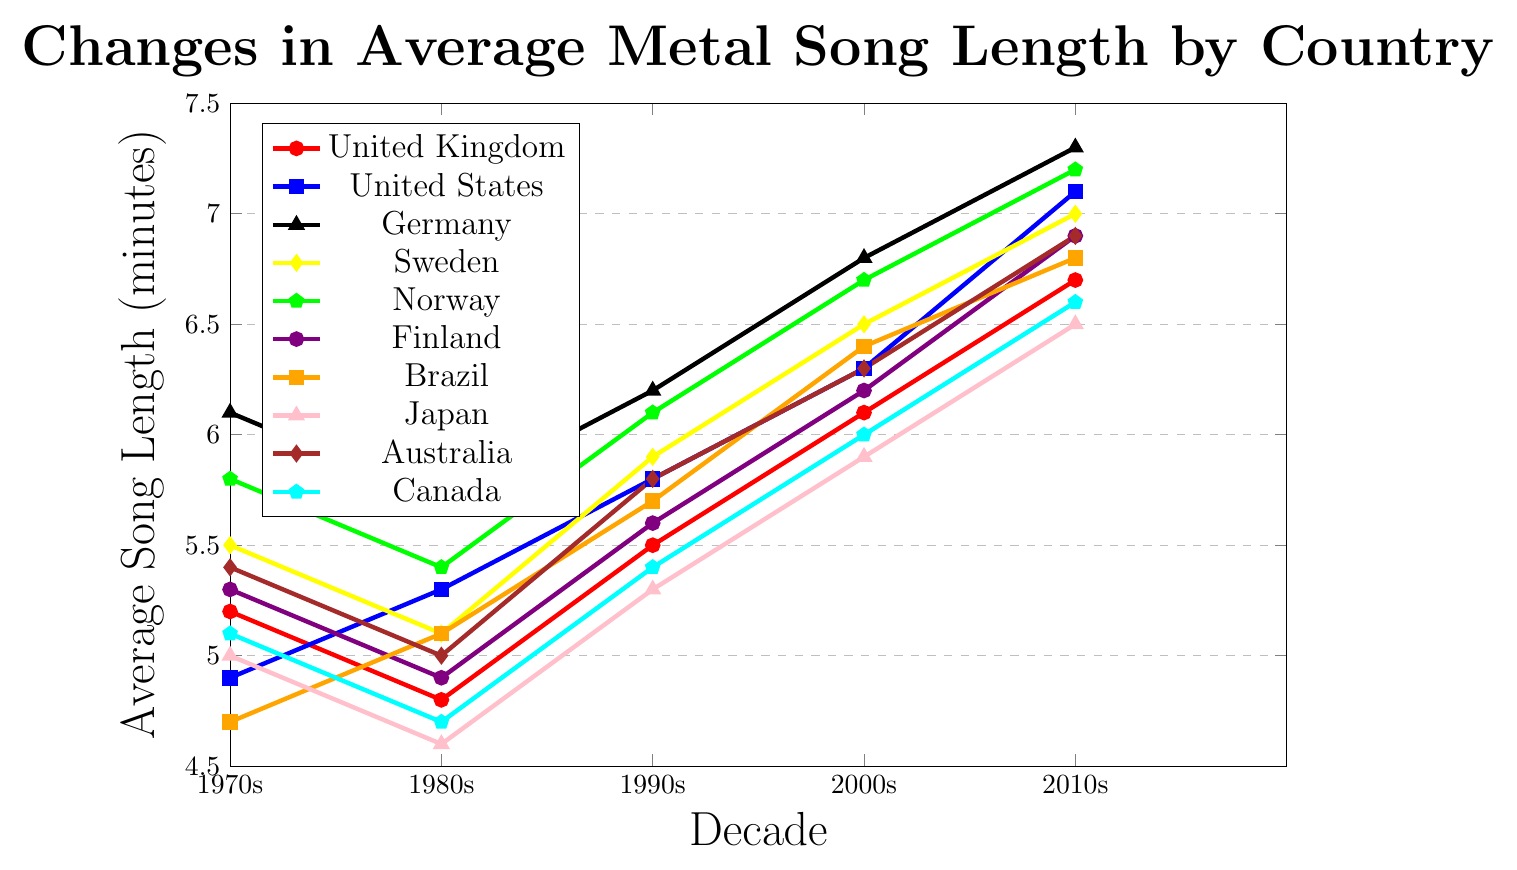Which country had the longest average song length in the 1970s? Look at the values for average song length in the 1970s for each country and find the highest value. Germany had an average song length of 6.1 minutes in the 1970s, which is the longest among all the countries.
Answer: Germany How did the average song length change for the United Kingdom from the 1980s to the 2010s? Refer to the average song lengths for the United Kingdom in the 1980s and the 2010s: 4.8 minutes and 6.7 minutes respectively. Subtract the value for the 1980s from the value for the 2010s: 6.7 - 4.8 = 1.9 minutes.
Answer: Increased by 1.9 minutes Which two countries had the closest average song lengths in the 2000s? Compare the values for average song lengths of all countries in the 2000s and find the two with the smallest difference. Finland and Canada have an average song length of 6.2 and 6.0 minutes respectively, and their difference is 0.2 minutes.
Answer: Finland and Canada Between which decades did Brazil see the biggest increase in average song length? Find the differences in average song length for Brazil between the decades: 1970s-1980s: 0.4, 1980s-1990s: 0.6, 1990s-2000s: 0.7, 2000s-2010s: 0.4. The biggest increase happens between the 1990s and 2000s at 0.7 minutes.
Answer: 1990s-2000s Which country consistently had an increase in average song length every decade? Check the values for each country over the decades. The United States saw continuous increases in each decade: 4.9, 5.3, 5.8, 6.3, 7.1 minutes.
Answer: United States How much higher was the average song length in Germany in the 2010s compared to Australia in the 1980s? Look at the average song length for Germany in the 2010s (7.3 minutes) and Australia in the 1980s (5.0 minutes) and find the difference: 7.3 - 5.0 = 2.3 minutes.
Answer: 2.3 minutes Which decade had the shortest average song length for Japan? Look at the values for Japan across all the decades and identify the shortest average song length. The shortest is 4.6 minutes in the 1980s.
Answer: 1980s Which country's average song length reached 7 minutes first: Sweden or Norway? Observe the data for Sweden and Norway: Sweden reached 7.0 minutes in the 2010s, while Norway reached 7.2 minutes in the same decade. Therefore, both reached 7 minutes in the 2010s, but Norway has a higher value.
Answer: Both in 2010s, but Norway higher 